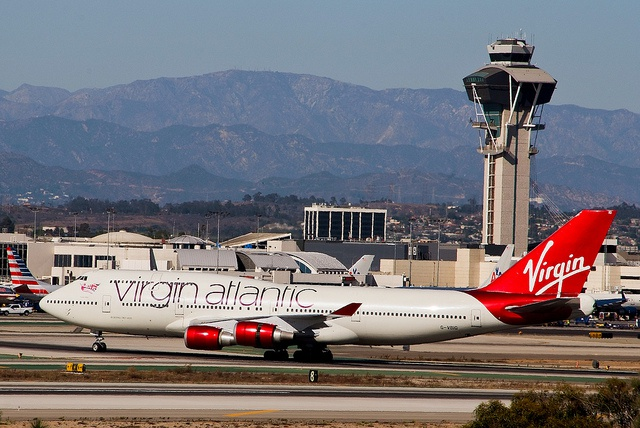Describe the objects in this image and their specific colors. I can see airplane in darkgray, lightgray, black, and red tones, airplane in darkgray, black, brown, and lightgray tones, airplane in darkgray, lightgray, and black tones, and truck in darkgray, black, lightgray, and gray tones in this image. 